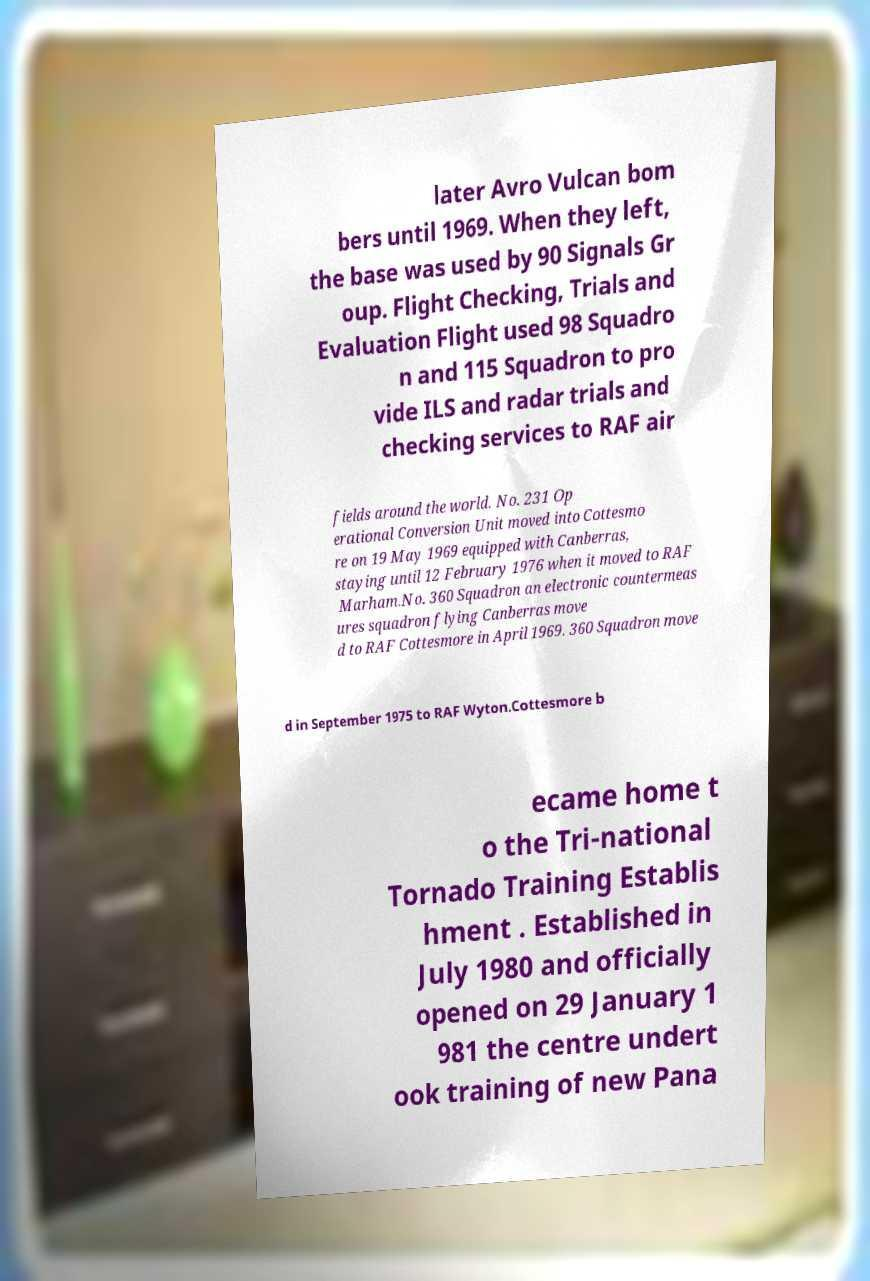Can you accurately transcribe the text from the provided image for me? later Avro Vulcan bom bers until 1969. When they left, the base was used by 90 Signals Gr oup. Flight Checking, Trials and Evaluation Flight used 98 Squadro n and 115 Squadron to pro vide ILS and radar trials and checking services to RAF air fields around the world. No. 231 Op erational Conversion Unit moved into Cottesmo re on 19 May 1969 equipped with Canberras, staying until 12 February 1976 when it moved to RAF Marham.No. 360 Squadron an electronic countermeas ures squadron flying Canberras move d to RAF Cottesmore in April 1969. 360 Squadron move d in September 1975 to RAF Wyton.Cottesmore b ecame home t o the Tri-national Tornado Training Establis hment . Established in July 1980 and officially opened on 29 January 1 981 the centre undert ook training of new Pana 